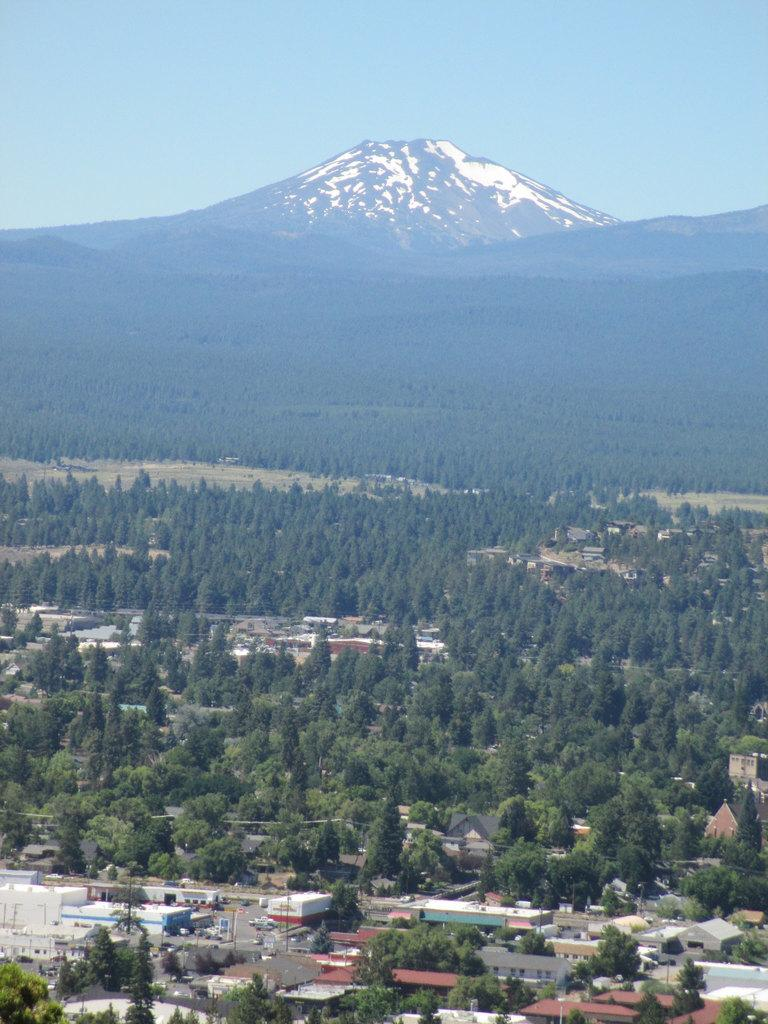What type of view is shown in the image? The image is an aerial view. What structures can be seen in the image? There are houses in the image. What type of vegetation is present in the image? There are trees in the image. What word is written on the frame of the image? There is no frame present in the image, as it is an aerial view. How many cars can be seen in the image? There are no cars visible in the image; it primarily features houses and trees. 